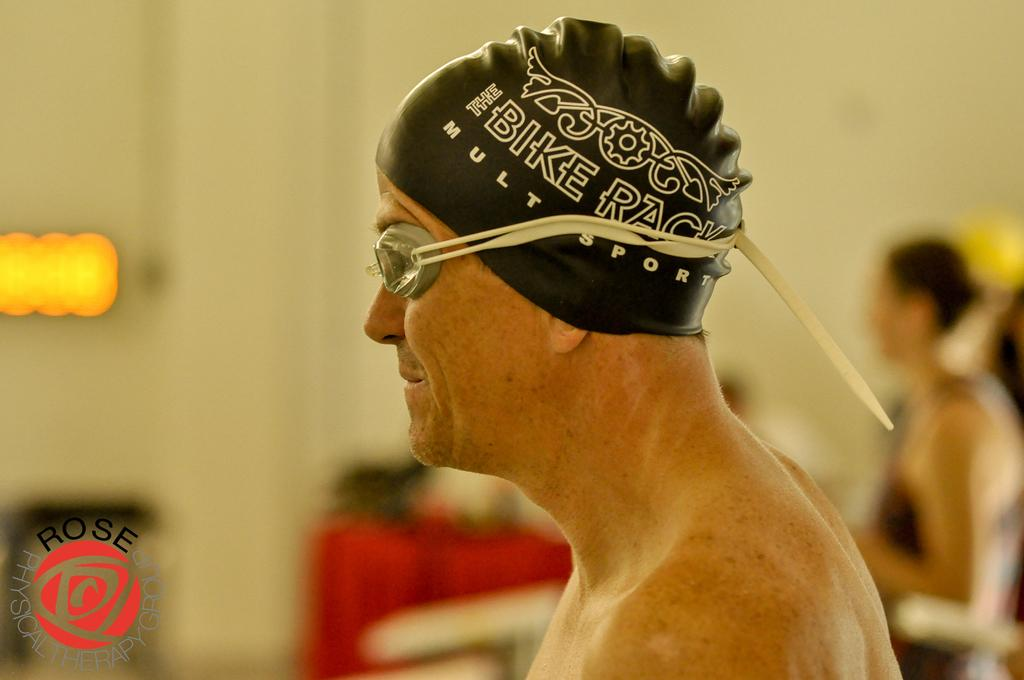Who is present in the image? There is a man in the image. Can you describe the background of the image? The background of the image is blurred. What type of pet is visible in the image? There is no pet present in the image. What is the man using to rest in the image? The image does not show the man resting or using any object for rest. 